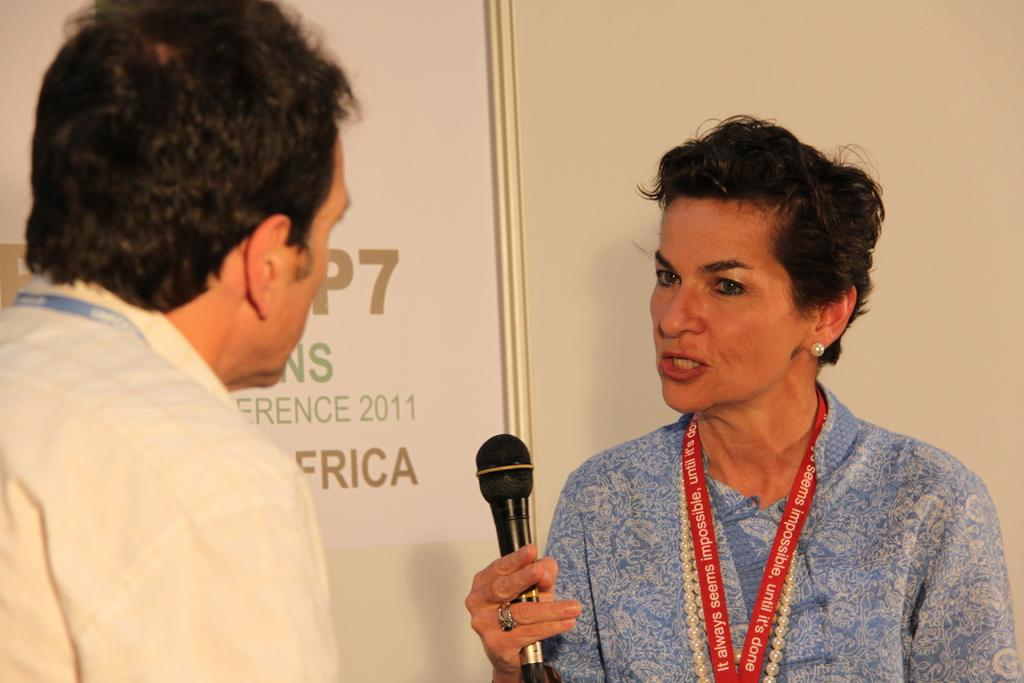How many people are in the image? There are two people in the image. What can be observed about the clothing of the people in the image? The people are wearing different color dresses. What is one person doing in the image? One person is holding a mic. What can be seen in the background of the image? There is a banner in the background of the image. Can you tell me how many rats are sitting on the girl's shoulder in the image? There are no rats or girls present in the image; it features two people wearing different color dresses, one of whom is holding a mic. 